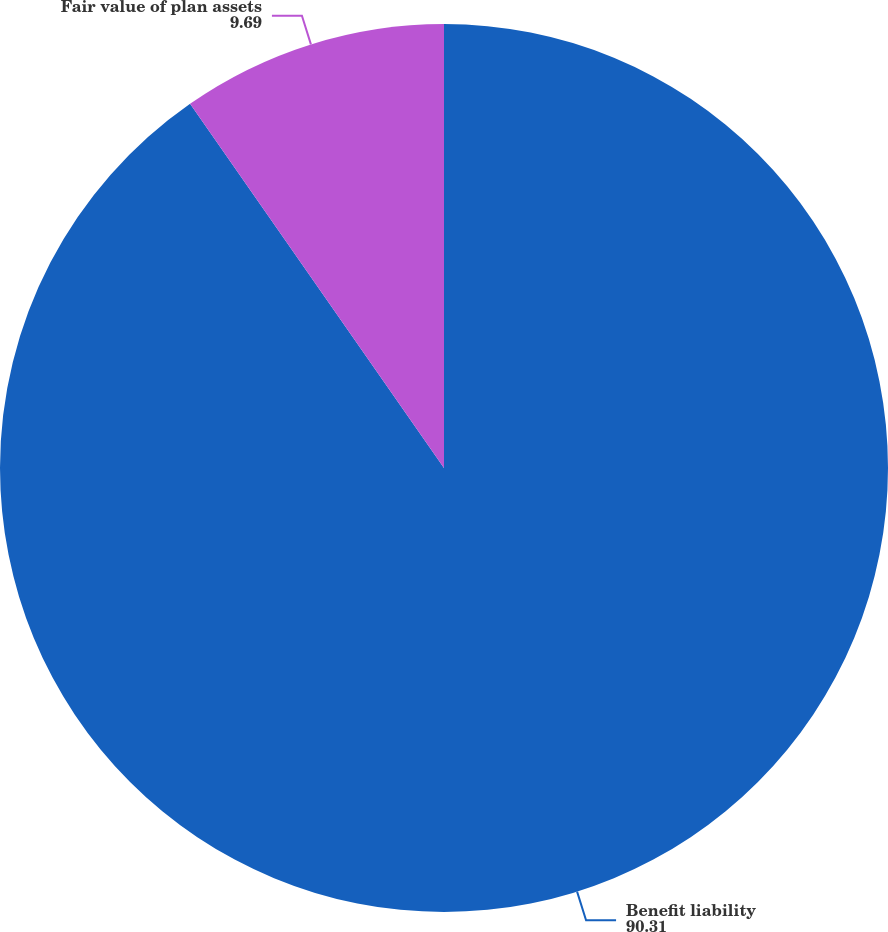<chart> <loc_0><loc_0><loc_500><loc_500><pie_chart><fcel>Benefit liability<fcel>Fair value of plan assets<nl><fcel>90.31%<fcel>9.69%<nl></chart> 